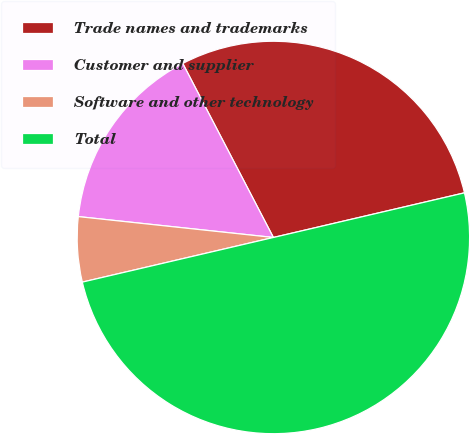Convert chart to OTSL. <chart><loc_0><loc_0><loc_500><loc_500><pie_chart><fcel>Trade names and trademarks<fcel>Customer and supplier<fcel>Software and other technology<fcel>Total<nl><fcel>28.99%<fcel>15.66%<fcel>5.35%<fcel>50.0%<nl></chart> 